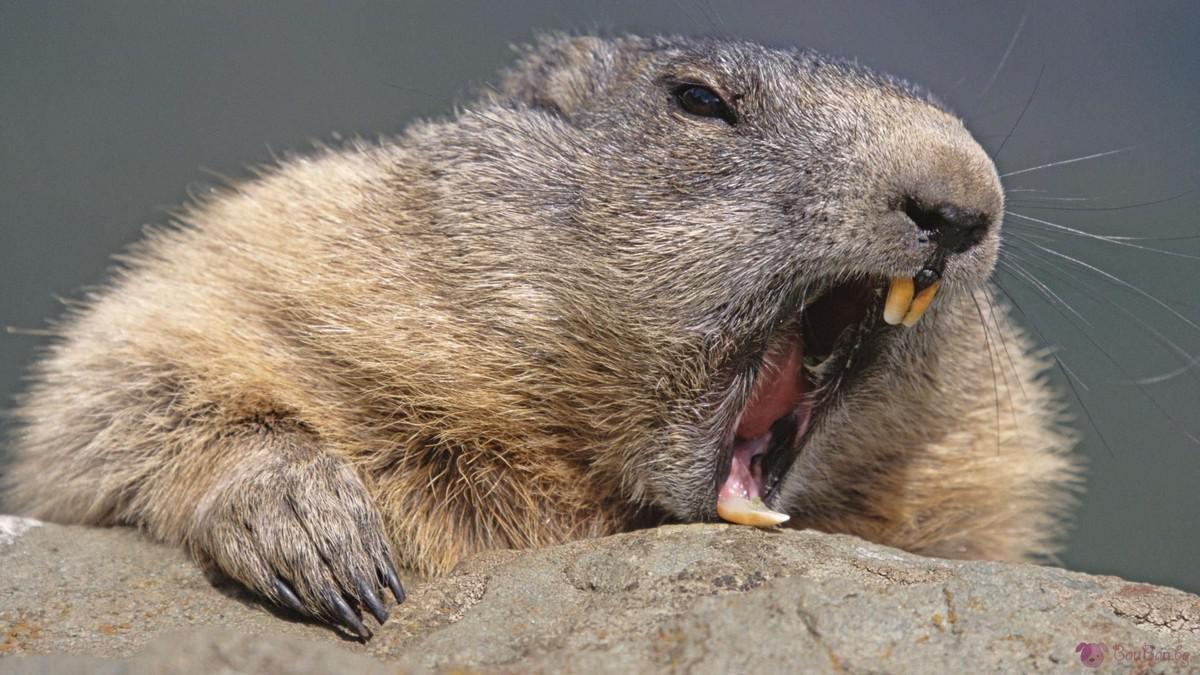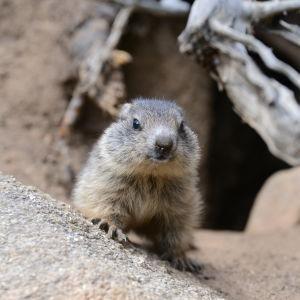The first image is the image on the left, the second image is the image on the right. For the images displayed, is the sentence "There is at least two rodents in the right image." factually correct? Answer yes or no. No. 